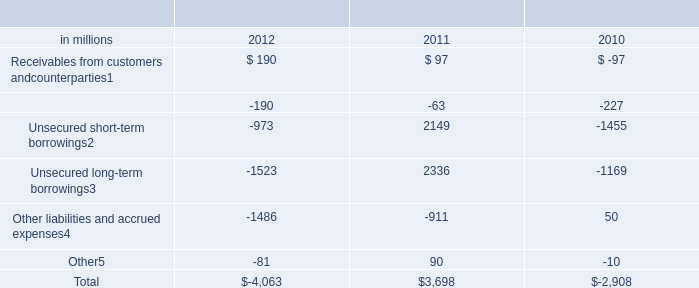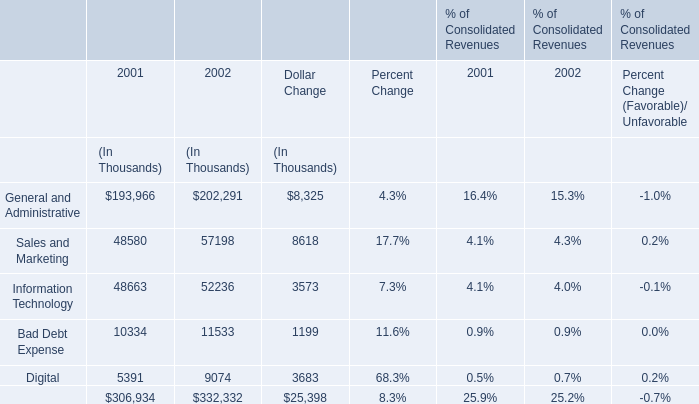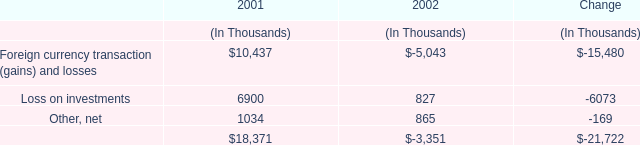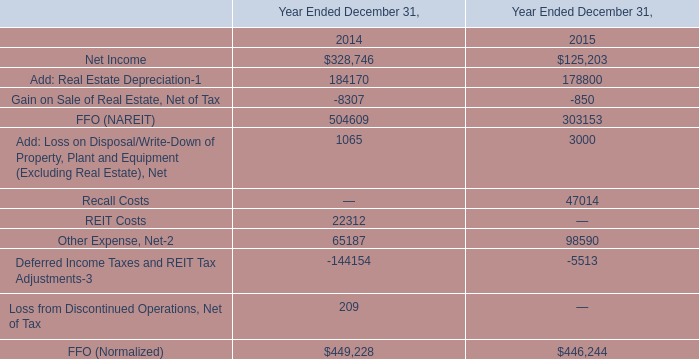What will Bad Debt Expense reach in 2003 if it continues to grow at its current rate? (in thousand) 
Computations: (11533 * (1 + ((11533 - 10334) / 10334)))
Answer: 12871.1137. 